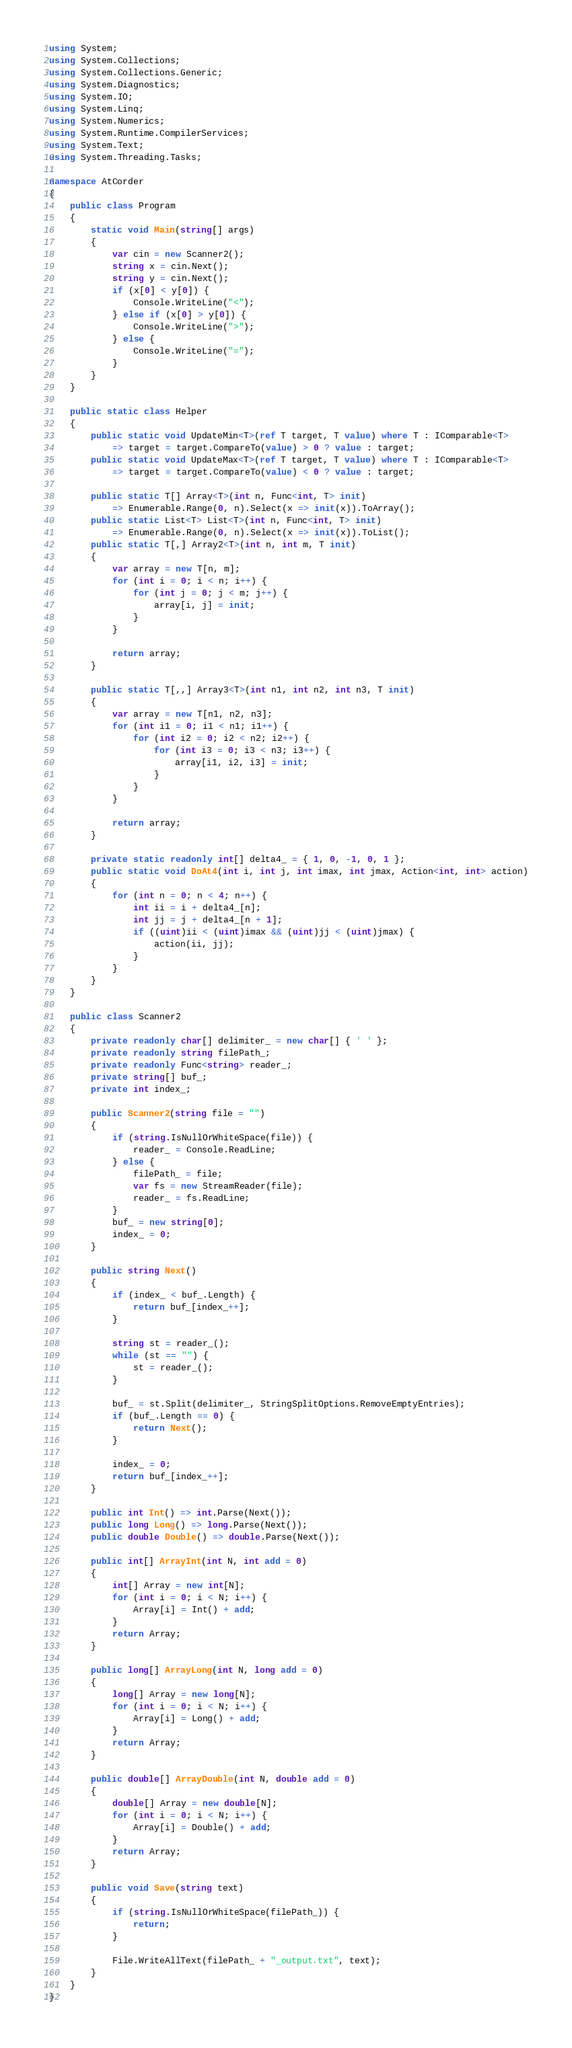Convert code to text. <code><loc_0><loc_0><loc_500><loc_500><_C#_>using System;
using System.Collections;
using System.Collections.Generic;
using System.Diagnostics;
using System.IO;
using System.Linq;
using System.Numerics;
using System.Runtime.CompilerServices;
using System.Text;
using System.Threading.Tasks;

namespace AtCorder
{
	public class Program
	{
		static void Main(string[] args)
		{
			var cin = new Scanner2();
			string x = cin.Next();
			string y = cin.Next();
			if (x[0] < y[0]) {
				Console.WriteLine("<");
			} else if (x[0] > y[0]) {
				Console.WriteLine(">");
			} else {
				Console.WriteLine("=");
			}
		}
	}

	public static class Helper
	{
		public static void UpdateMin<T>(ref T target, T value) where T : IComparable<T>
			=> target = target.CompareTo(value) > 0 ? value : target;
		public static void UpdateMax<T>(ref T target, T value) where T : IComparable<T>
			=> target = target.CompareTo(value) < 0 ? value : target;

		public static T[] Array<T>(int n, Func<int, T> init)
			=> Enumerable.Range(0, n).Select(x => init(x)).ToArray();
		public static List<T> List<T>(int n, Func<int, T> init)
			=> Enumerable.Range(0, n).Select(x => init(x)).ToList();
		public static T[,] Array2<T>(int n, int m, T init)
		{
			var array = new T[n, m];
			for (int i = 0; i < n; i++) {
				for (int j = 0; j < m; j++) {
					array[i, j] = init;
				}
			}

			return array;
		}

		public static T[,,] Array3<T>(int n1, int n2, int n3, T init)
		{
			var array = new T[n1, n2, n3];
			for (int i1 = 0; i1 < n1; i1++) {
				for (int i2 = 0; i2 < n2; i2++) {
					for (int i3 = 0; i3 < n3; i3++) {
						array[i1, i2, i3] = init;
					}
				}
			}

			return array;
		}

		private static readonly int[] delta4_ = { 1, 0, -1, 0, 1 };
		public static void DoAt4(int i, int j, int imax, int jmax, Action<int, int> action)
		{
			for (int n = 0; n < 4; n++) {
				int ii = i + delta4_[n];
				int jj = j + delta4_[n + 1];
				if ((uint)ii < (uint)imax && (uint)jj < (uint)jmax) {
					action(ii, jj);
				}
			}
		}
	}

	public class Scanner2
	{
		private readonly char[] delimiter_ = new char[] { ' ' };
		private readonly string filePath_;
		private readonly Func<string> reader_;
		private string[] buf_;
		private int index_;

		public Scanner2(string file = "")
		{
			if (string.IsNullOrWhiteSpace(file)) {
				reader_ = Console.ReadLine;
			} else {
				filePath_ = file;
				var fs = new StreamReader(file);
				reader_ = fs.ReadLine;
			}
			buf_ = new string[0];
			index_ = 0;
		}

		public string Next()
		{
			if (index_ < buf_.Length) {
				return buf_[index_++];
			}

			string st = reader_();
			while (st == "") {
				st = reader_();
			}

			buf_ = st.Split(delimiter_, StringSplitOptions.RemoveEmptyEntries);
			if (buf_.Length == 0) {
				return Next();
			}

			index_ = 0;
			return buf_[index_++];
		}

		public int Int() => int.Parse(Next());
		public long Long() => long.Parse(Next());
		public double Double() => double.Parse(Next());

		public int[] ArrayInt(int N, int add = 0)
		{
			int[] Array = new int[N];
			for (int i = 0; i < N; i++) {
				Array[i] = Int() + add;
			}
			return Array;
		}

		public long[] ArrayLong(int N, long add = 0)
		{
			long[] Array = new long[N];
			for (int i = 0; i < N; i++) {
				Array[i] = Long() + add;
			}
			return Array;
		}

		public double[] ArrayDouble(int N, double add = 0)
		{
			double[] Array = new double[N];
			for (int i = 0; i < N; i++) {
				Array[i] = Double() + add;
			}
			return Array;
		}

		public void Save(string text)
		{
			if (string.IsNullOrWhiteSpace(filePath_)) {
				return;
			}

			File.WriteAllText(filePath_ + "_output.txt", text);
		}
	}
}</code> 